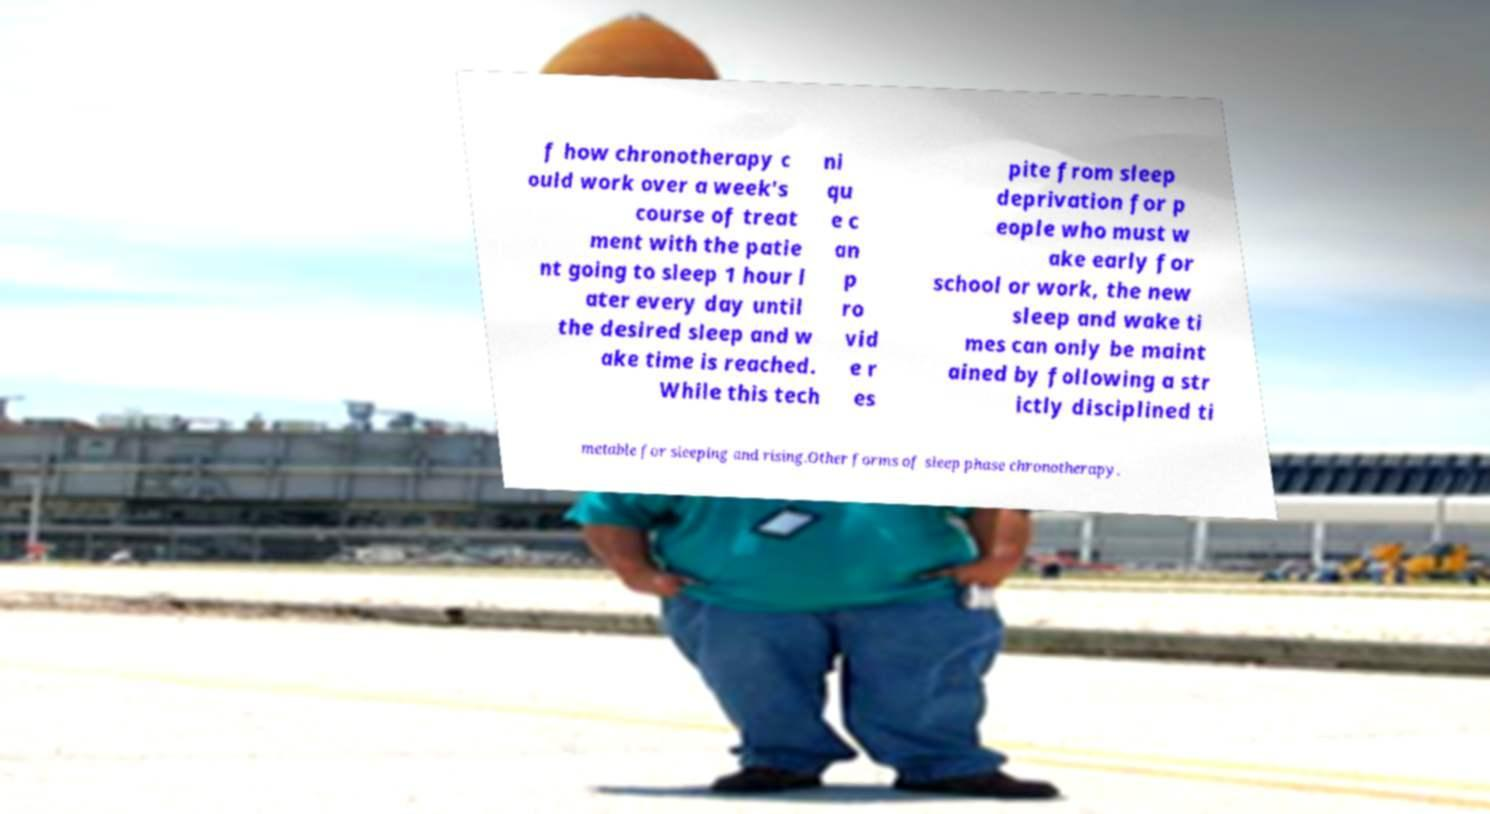For documentation purposes, I need the text within this image transcribed. Could you provide that? f how chronotherapy c ould work over a week's course of treat ment with the patie nt going to sleep 1 hour l ater every day until the desired sleep and w ake time is reached. While this tech ni qu e c an p ro vid e r es pite from sleep deprivation for p eople who must w ake early for school or work, the new sleep and wake ti mes can only be maint ained by following a str ictly disciplined ti metable for sleeping and rising.Other forms of sleep phase chronotherapy. 